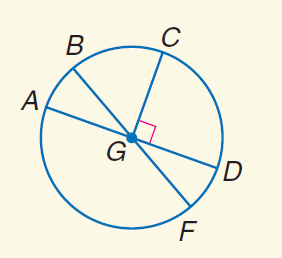Answer the mathemtical geometry problem and directly provide the correct option letter.
Question: In \odot G, m \angle A G B = 30 and C G \perp G D. Find m \widehat B C.
Choices: A: 30 B: 45 C: 60 D: 90 C 